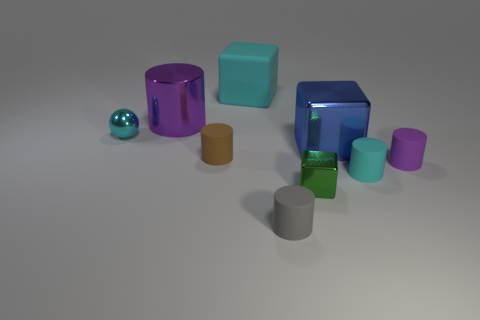Do the cube that is to the left of the small green metal cube and the small sphere have the same color?
Your answer should be compact. Yes. What number of other things are the same shape as the gray matte object?
Ensure brevity in your answer.  4. What number of other objects are there of the same material as the cyan block?
Make the answer very short. 4. What is the material of the small cyan object that is to the right of the rubber thing on the left side of the cube behind the purple shiny thing?
Ensure brevity in your answer.  Rubber. Do the cyan block and the cyan cylinder have the same material?
Offer a very short reply. Yes. What number of cylinders are big purple things or brown rubber objects?
Give a very brief answer. 2. What color is the large block that is behind the cyan metal sphere?
Offer a terse response. Cyan. How many matte things are either small cyan things or blue things?
Offer a very short reply. 1. The purple cylinder in front of the big cube that is in front of the tiny ball is made of what material?
Your answer should be compact. Rubber. There is a cylinder that is the same color as the big rubber thing; what is it made of?
Your answer should be compact. Rubber. 